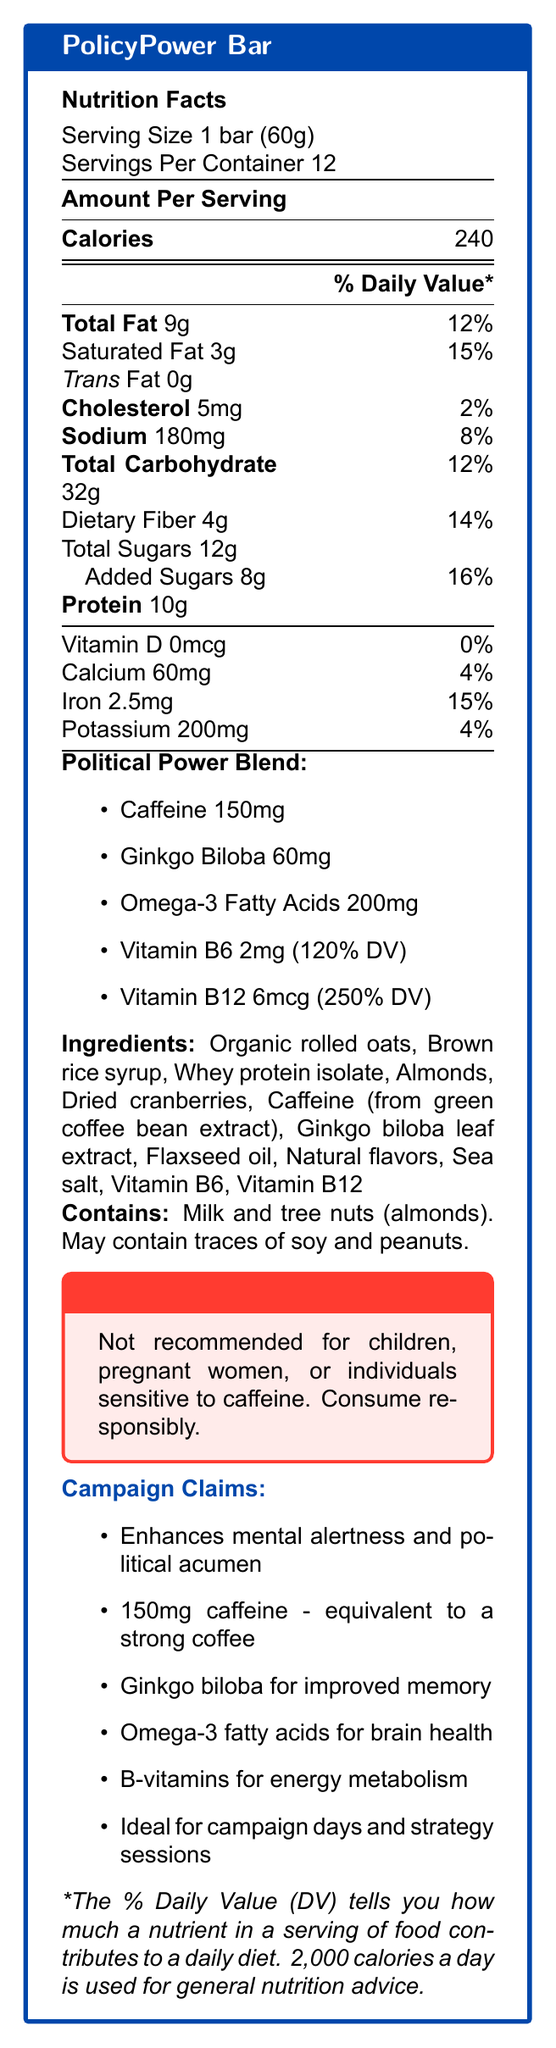what is the serving size of the PolicyPower Bar? The serving size is clearly mentioned under the Nutrition Facts section as "1 bar (60g)".
Answer: 1 bar (60g) how many servings are there per container? It states "Servings Per Container: 12" right after the serving size information.
Answer: 12 how many grams of protein does the PolicyPower Bar contain per serving? Protein content is listed under the Nutrition Facts section and is shown as "Protein 10g".
Answer: 10g what is the amount of caffeine in the PolicyPower Bar? The amount of caffeine is listed under the "Political Power Blend" and it states "Caffeine 150mg".
Answer: 150mg how much dietary fiber is in one serving of the PolicyPower Bar? Dietary Fiber content is listed under the Nutrition Facts section as "Dietary Fiber 4g".
Answer: 4g estimate the total calories in the whole container of PolicyPower Bars Each bar has 240 calories and there are 12 bars in one container. So, 240 calories * 12 bars = 2880 calories.
Answer: 2880 calories which ingredient is not in the PolicyPower Bar? A. Organic rolled oats B. Brown rice syrup C. Soy protein isolate D. Almonds The ingredients listed include "Organic rolled oats", "Brown rice syrup", "Almonds", but no "Soy protein isolate".
Answer: C. Soy protein isolate how many grams of added sugars are in one serving? The "Added Sugars" amount is listed separately under the Total Sugars as "Added Sugars 8g".
Answer: 8g which of the following vitamins are included in the Political Power Blend? A. Vitamin C B. Vitamin D C. Vitamin B6 D. Vitamin A Vitamin B6 is listed under the "Political Power Blend", but Vitamins C, D, and A are not mentioned.
Answer: C. Vitamin B6 is the PolicyPower Bar suitable for someone sensitive to caffeine? The warning explicitly states that the product is "Not recommended for children, pregnant women, or individuals sensitive to caffeine".
Answer: No summarize the main intention of the PolicyPower Bar based on the document. The claims section includes details of how the ingredients aim to improve mental alertness and support brain function and energy metabolism.
Answer: The PolicyPower Bar is designed to enhance mental alertness and political acumen, containing 150mg of caffeine, ginkgo biloba for improved memory, omega-3 fatty acids for brain health, and B-vitamins for energy metabolism, making it ideal for long campaign days and late-night strategy sessions. how much iron is in one serving? The Nutrition Facts section lists iron content as "Iron 2.5mg".
Answer: 2.5mg what is the percentage of daily value for Saturated Fat? The percent daily value for Saturated Fat is stated as 15% in the Nutrition Facts section.
Answer: 15% how much omega-3 fatty acids does each PolicyPower Bar have? Under the "Political Power Blend," it lists omega-3 fatty acids content as 200mg.
Answer: 200mg what are the potential allergens listed in the PolicyPower Bar? The allergen information explicitly states that the bar contains milk and tree nuts (almonds) and may contain traces of soy and peanuts.
Answer: Milk and tree nuts (almonds). May contain traces of soy and peanuts. what is the amount of vitamin D in the PolicyPower Bar? The Vitamin D content is listed as "Vitamin D 0mcg" in the Nutrition Facts section.
Answer: 0mcg does the PolicyPower Bar contain ginkgo biloba? The "Political Power Blend" list includes "Ginkgo Biloba 60mg".
Answer: Yes which particular group of people should avoid consuming the PolicyPower Bar? The warning section clearly states that these groups should avoid the product.
Answer: Children, pregnant women, and individuals sensitive to caffeine how much is the daily value percentage of vitamin B12 provided by the PolicyPower Bar? The "Political Power Blend" lists Vitamin B12 as "6mcg (250% DV)".
Answer: 250% how much calcium is there in one serving? The Nutrition Facts section lists calcium content as "Calcium 60mg".
Answer: 60mg 